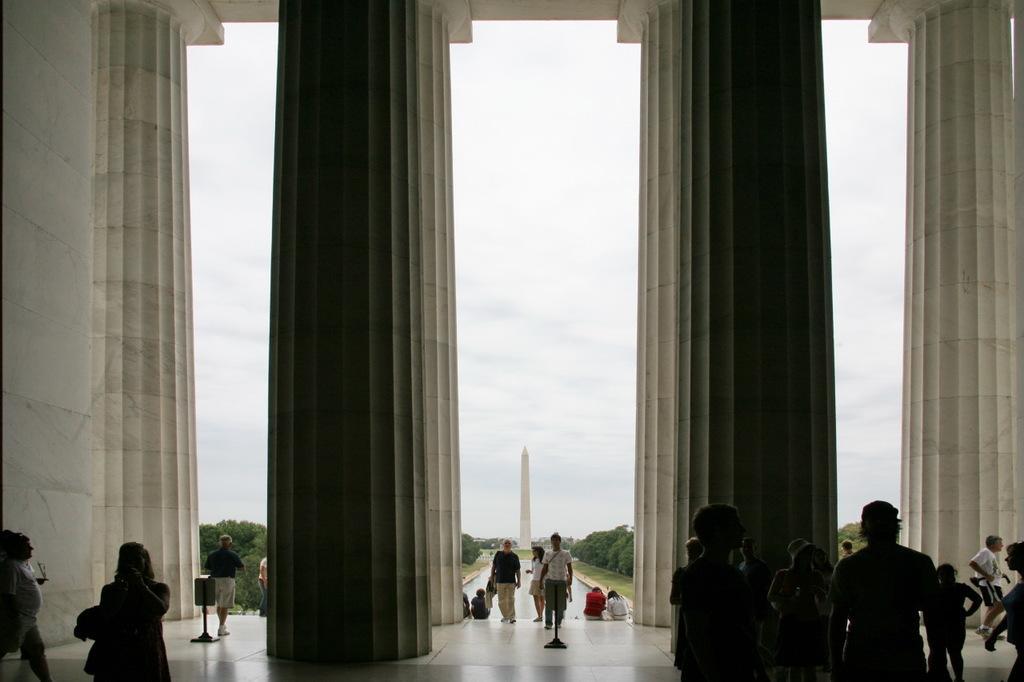Describe this image in one or two sentences. At the bottom there are many people on the floor. Here I can see four pillars. In the background there are some trees and a tower. At the top of the image I can see the sky. 